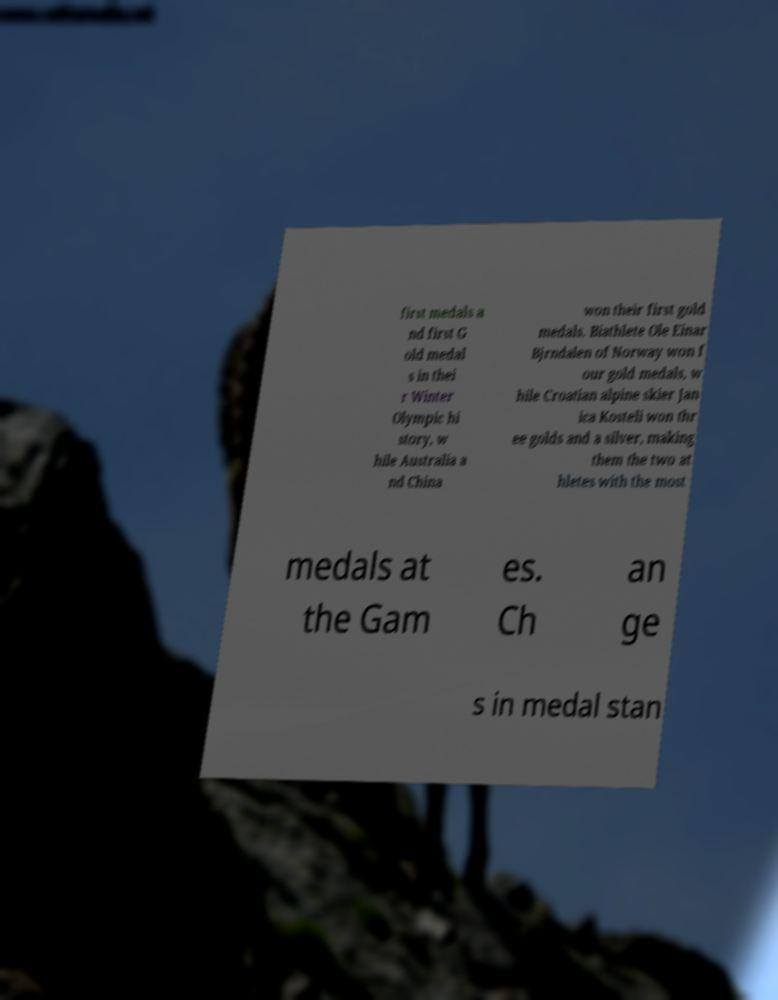Can you read and provide the text displayed in the image?This photo seems to have some interesting text. Can you extract and type it out for me? first medals a nd first G old medal s in thei r Winter Olympic hi story, w hile Australia a nd China won their first gold medals. Biathlete Ole Einar Bjrndalen of Norway won f our gold medals, w hile Croatian alpine skier Jan ica Kosteli won thr ee golds and a silver, making them the two at hletes with the most medals at the Gam es. Ch an ge s in medal stan 